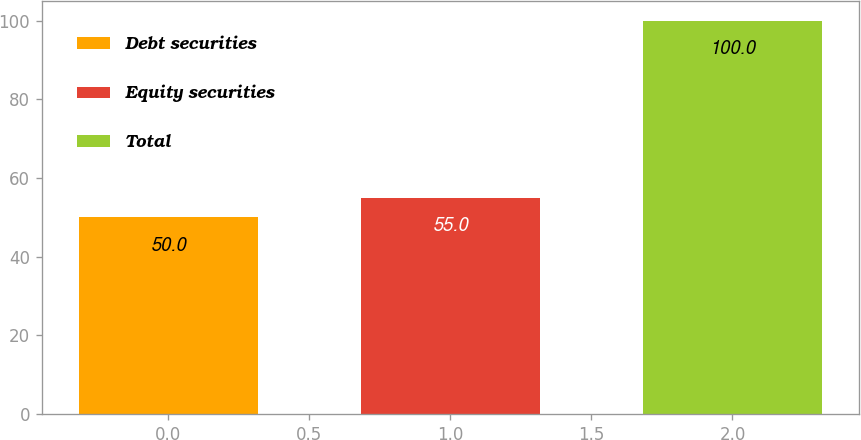<chart> <loc_0><loc_0><loc_500><loc_500><bar_chart><fcel>Debt securities<fcel>Equity securities<fcel>Total<nl><fcel>50<fcel>55<fcel>100<nl></chart> 